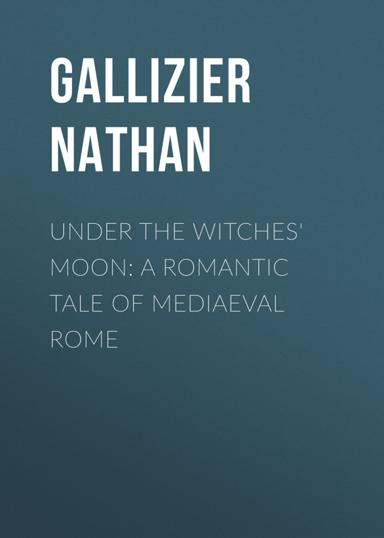What is the title and author of the book mentioned in the image?
 The title of the book is "Under the Witches' Moon" and the author is Nathan Gallizier. What is the setting of "Under the Witches' Moon"? The setting of "Under the Witches' Moon" is mediaeval Rome. 